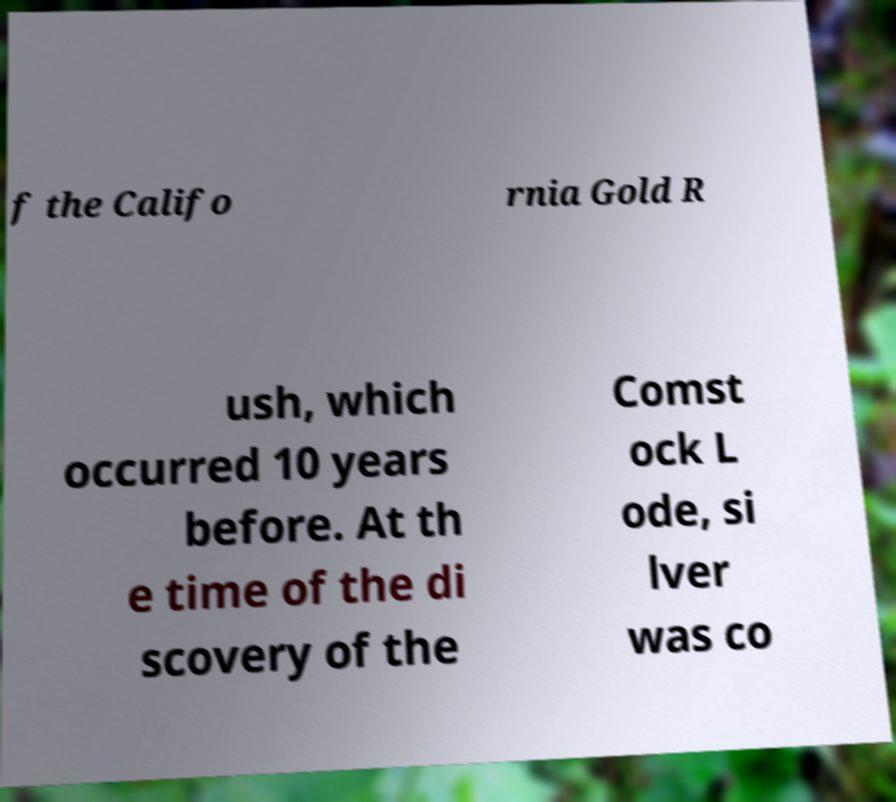Could you assist in decoding the text presented in this image and type it out clearly? f the Califo rnia Gold R ush, which occurred 10 years before. At th e time of the di scovery of the Comst ock L ode, si lver was co 